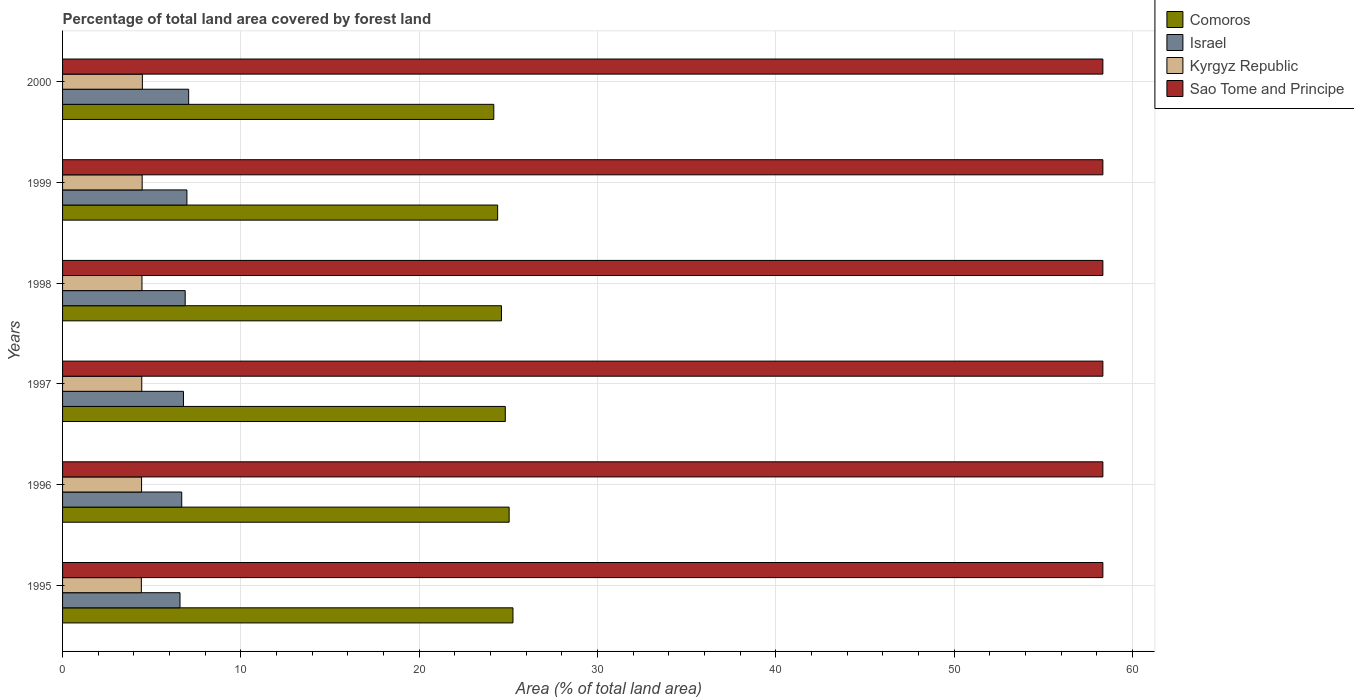How many bars are there on the 1st tick from the top?
Offer a terse response. 4. How many bars are there on the 4th tick from the bottom?
Ensure brevity in your answer.  4. What is the percentage of forest land in Sao Tome and Principe in 1998?
Ensure brevity in your answer.  58.33. Across all years, what is the maximum percentage of forest land in Kyrgyz Republic?
Provide a short and direct response. 4.47. Across all years, what is the minimum percentage of forest land in Kyrgyz Republic?
Keep it short and to the point. 4.42. What is the total percentage of forest land in Comoros in the graph?
Ensure brevity in your answer.  148.31. What is the difference between the percentage of forest land in Israel in 1996 and that in 2000?
Provide a short and direct response. -0.39. What is the difference between the percentage of forest land in Comoros in 1995 and the percentage of forest land in Sao Tome and Principe in 1998?
Your response must be concise. -33.08. What is the average percentage of forest land in Sao Tome and Principe per year?
Ensure brevity in your answer.  58.33. In the year 1998, what is the difference between the percentage of forest land in Kyrgyz Republic and percentage of forest land in Sao Tome and Principe?
Provide a succinct answer. -53.88. In how many years, is the percentage of forest land in Comoros greater than 18 %?
Your answer should be very brief. 6. What is the ratio of the percentage of forest land in Israel in 1995 to that in 1999?
Give a very brief answer. 0.94. Is the percentage of forest land in Israel in 1997 less than that in 1998?
Your response must be concise. Yes. What is the difference between the highest and the second highest percentage of forest land in Sao Tome and Principe?
Your answer should be very brief. 0. What is the difference between the highest and the lowest percentage of forest land in Israel?
Provide a short and direct response. 0.49. What does the 1st bar from the bottom in 1999 represents?
Your answer should be very brief. Comoros. Is it the case that in every year, the sum of the percentage of forest land in Sao Tome and Principe and percentage of forest land in Comoros is greater than the percentage of forest land in Kyrgyz Republic?
Provide a succinct answer. Yes. Are all the bars in the graph horizontal?
Offer a very short reply. Yes. How many years are there in the graph?
Provide a short and direct response. 6. Does the graph contain any zero values?
Provide a succinct answer. No. How many legend labels are there?
Offer a terse response. 4. How are the legend labels stacked?
Offer a terse response. Vertical. What is the title of the graph?
Make the answer very short. Percentage of total land area covered by forest land. What is the label or title of the X-axis?
Ensure brevity in your answer.  Area (% of total land area). What is the label or title of the Y-axis?
Offer a terse response. Years. What is the Area (% of total land area) of Comoros in 1995?
Offer a very short reply. 25.26. What is the Area (% of total land area) of Israel in 1995?
Offer a terse response. 6.59. What is the Area (% of total land area) of Kyrgyz Republic in 1995?
Your response must be concise. 4.42. What is the Area (% of total land area) of Sao Tome and Principe in 1995?
Offer a very short reply. 58.33. What is the Area (% of total land area) in Comoros in 1996?
Your answer should be compact. 25.04. What is the Area (% of total land area) of Israel in 1996?
Your answer should be very brief. 6.68. What is the Area (% of total land area) in Kyrgyz Republic in 1996?
Make the answer very short. 4.43. What is the Area (% of total land area) in Sao Tome and Principe in 1996?
Provide a succinct answer. 58.33. What is the Area (% of total land area) in Comoros in 1997?
Your answer should be very brief. 24.83. What is the Area (% of total land area) in Israel in 1997?
Offer a terse response. 6.78. What is the Area (% of total land area) in Kyrgyz Republic in 1997?
Offer a very short reply. 4.44. What is the Area (% of total land area) in Sao Tome and Principe in 1997?
Your answer should be compact. 58.33. What is the Area (% of total land area) of Comoros in 1998?
Provide a short and direct response. 24.61. What is the Area (% of total land area) in Israel in 1998?
Offer a very short reply. 6.88. What is the Area (% of total land area) of Kyrgyz Republic in 1998?
Offer a very short reply. 4.45. What is the Area (% of total land area) in Sao Tome and Principe in 1998?
Keep it short and to the point. 58.33. What is the Area (% of total land area) in Comoros in 1999?
Ensure brevity in your answer.  24.4. What is the Area (% of total land area) in Israel in 1999?
Ensure brevity in your answer.  6.97. What is the Area (% of total land area) of Kyrgyz Republic in 1999?
Provide a short and direct response. 4.46. What is the Area (% of total land area) in Sao Tome and Principe in 1999?
Give a very brief answer. 58.33. What is the Area (% of total land area) in Comoros in 2000?
Provide a short and direct response. 24.18. What is the Area (% of total land area) of Israel in 2000?
Provide a succinct answer. 7.07. What is the Area (% of total land area) in Kyrgyz Republic in 2000?
Offer a terse response. 4.47. What is the Area (% of total land area) of Sao Tome and Principe in 2000?
Provide a short and direct response. 58.33. Across all years, what is the maximum Area (% of total land area) in Comoros?
Give a very brief answer. 25.26. Across all years, what is the maximum Area (% of total land area) in Israel?
Offer a very short reply. 7.07. Across all years, what is the maximum Area (% of total land area) of Kyrgyz Republic?
Provide a short and direct response. 4.47. Across all years, what is the maximum Area (% of total land area) of Sao Tome and Principe?
Offer a terse response. 58.33. Across all years, what is the minimum Area (% of total land area) of Comoros?
Give a very brief answer. 24.18. Across all years, what is the minimum Area (% of total land area) of Israel?
Keep it short and to the point. 6.59. Across all years, what is the minimum Area (% of total land area) of Kyrgyz Republic?
Your answer should be compact. 4.42. Across all years, what is the minimum Area (% of total land area) in Sao Tome and Principe?
Make the answer very short. 58.33. What is the total Area (% of total land area) of Comoros in the graph?
Give a very brief answer. 148.31. What is the total Area (% of total land area) in Israel in the graph?
Your answer should be compact. 40.97. What is the total Area (% of total land area) of Kyrgyz Republic in the graph?
Ensure brevity in your answer.  26.68. What is the total Area (% of total land area) of Sao Tome and Principe in the graph?
Your answer should be very brief. 350. What is the difference between the Area (% of total land area) of Comoros in 1995 and that in 1996?
Give a very brief answer. 0.21. What is the difference between the Area (% of total land area) of Israel in 1995 and that in 1996?
Provide a short and direct response. -0.1. What is the difference between the Area (% of total land area) of Kyrgyz Republic in 1995 and that in 1996?
Your response must be concise. -0.01. What is the difference between the Area (% of total land area) of Sao Tome and Principe in 1995 and that in 1996?
Offer a very short reply. 0. What is the difference between the Area (% of total land area) in Comoros in 1995 and that in 1997?
Ensure brevity in your answer.  0.43. What is the difference between the Area (% of total land area) in Israel in 1995 and that in 1997?
Your response must be concise. -0.19. What is the difference between the Area (% of total land area) of Kyrgyz Republic in 1995 and that in 1997?
Your answer should be very brief. -0.02. What is the difference between the Area (% of total land area) in Comoros in 1995 and that in 1998?
Provide a succinct answer. 0.64. What is the difference between the Area (% of total land area) in Israel in 1995 and that in 1998?
Your response must be concise. -0.29. What is the difference between the Area (% of total land area) of Kyrgyz Republic in 1995 and that in 1998?
Offer a terse response. -0.03. What is the difference between the Area (% of total land area) of Comoros in 1995 and that in 1999?
Keep it short and to the point. 0.86. What is the difference between the Area (% of total land area) in Israel in 1995 and that in 1999?
Give a very brief answer. -0.39. What is the difference between the Area (% of total land area) in Kyrgyz Republic in 1995 and that in 1999?
Make the answer very short. -0.05. What is the difference between the Area (% of total land area) in Sao Tome and Principe in 1995 and that in 1999?
Offer a very short reply. 0. What is the difference between the Area (% of total land area) in Comoros in 1995 and that in 2000?
Make the answer very short. 1.07. What is the difference between the Area (% of total land area) in Israel in 1995 and that in 2000?
Provide a short and direct response. -0.49. What is the difference between the Area (% of total land area) in Kyrgyz Republic in 1995 and that in 2000?
Make the answer very short. -0.06. What is the difference between the Area (% of total land area) of Comoros in 1996 and that in 1997?
Your answer should be very brief. 0.21. What is the difference between the Area (% of total land area) of Israel in 1996 and that in 1997?
Keep it short and to the point. -0.1. What is the difference between the Area (% of total land area) of Kyrgyz Republic in 1996 and that in 1997?
Your answer should be very brief. -0.01. What is the difference between the Area (% of total land area) in Comoros in 1996 and that in 1998?
Your response must be concise. 0.43. What is the difference between the Area (% of total land area) in Israel in 1996 and that in 1998?
Your response must be concise. -0.19. What is the difference between the Area (% of total land area) in Kyrgyz Republic in 1996 and that in 1998?
Your response must be concise. -0.02. What is the difference between the Area (% of total land area) in Comoros in 1996 and that in 1999?
Give a very brief answer. 0.64. What is the difference between the Area (% of total land area) in Israel in 1996 and that in 1999?
Provide a succinct answer. -0.29. What is the difference between the Area (% of total land area) of Kyrgyz Republic in 1996 and that in 1999?
Your response must be concise. -0.03. What is the difference between the Area (% of total land area) of Sao Tome and Principe in 1996 and that in 1999?
Provide a succinct answer. 0. What is the difference between the Area (% of total land area) in Comoros in 1996 and that in 2000?
Keep it short and to the point. 0.86. What is the difference between the Area (% of total land area) in Israel in 1996 and that in 2000?
Provide a short and direct response. -0.39. What is the difference between the Area (% of total land area) in Kyrgyz Republic in 1996 and that in 2000?
Your response must be concise. -0.05. What is the difference between the Area (% of total land area) in Sao Tome and Principe in 1996 and that in 2000?
Your answer should be compact. 0. What is the difference between the Area (% of total land area) in Comoros in 1997 and that in 1998?
Give a very brief answer. 0.21. What is the difference between the Area (% of total land area) in Israel in 1997 and that in 1998?
Make the answer very short. -0.1. What is the difference between the Area (% of total land area) of Kyrgyz Republic in 1997 and that in 1998?
Give a very brief answer. -0.01. What is the difference between the Area (% of total land area) in Sao Tome and Principe in 1997 and that in 1998?
Your answer should be compact. 0. What is the difference between the Area (% of total land area) in Comoros in 1997 and that in 1999?
Make the answer very short. 0.43. What is the difference between the Area (% of total land area) of Israel in 1997 and that in 1999?
Your answer should be compact. -0.19. What is the difference between the Area (% of total land area) of Kyrgyz Republic in 1997 and that in 1999?
Make the answer very short. -0.02. What is the difference between the Area (% of total land area) in Sao Tome and Principe in 1997 and that in 1999?
Your response must be concise. 0. What is the difference between the Area (% of total land area) in Comoros in 1997 and that in 2000?
Your response must be concise. 0.64. What is the difference between the Area (% of total land area) in Israel in 1997 and that in 2000?
Keep it short and to the point. -0.29. What is the difference between the Area (% of total land area) in Kyrgyz Republic in 1997 and that in 2000?
Keep it short and to the point. -0.03. What is the difference between the Area (% of total land area) in Comoros in 1998 and that in 1999?
Your answer should be compact. 0.21. What is the difference between the Area (% of total land area) of Israel in 1998 and that in 1999?
Your answer should be very brief. -0.1. What is the difference between the Area (% of total land area) of Kyrgyz Republic in 1998 and that in 1999?
Offer a very short reply. -0.01. What is the difference between the Area (% of total land area) of Comoros in 1998 and that in 2000?
Keep it short and to the point. 0.43. What is the difference between the Area (% of total land area) in Israel in 1998 and that in 2000?
Make the answer very short. -0.19. What is the difference between the Area (% of total land area) in Kyrgyz Republic in 1998 and that in 2000?
Offer a very short reply. -0.02. What is the difference between the Area (% of total land area) of Sao Tome and Principe in 1998 and that in 2000?
Offer a very short reply. 0. What is the difference between the Area (% of total land area) of Comoros in 1999 and that in 2000?
Make the answer very short. 0.21. What is the difference between the Area (% of total land area) of Israel in 1999 and that in 2000?
Ensure brevity in your answer.  -0.1. What is the difference between the Area (% of total land area) in Kyrgyz Republic in 1999 and that in 2000?
Your answer should be compact. -0.01. What is the difference between the Area (% of total land area) of Sao Tome and Principe in 1999 and that in 2000?
Provide a short and direct response. 0. What is the difference between the Area (% of total land area) in Comoros in 1995 and the Area (% of total land area) in Israel in 1996?
Your response must be concise. 18.57. What is the difference between the Area (% of total land area) of Comoros in 1995 and the Area (% of total land area) of Kyrgyz Republic in 1996?
Ensure brevity in your answer.  20.83. What is the difference between the Area (% of total land area) in Comoros in 1995 and the Area (% of total land area) in Sao Tome and Principe in 1996?
Ensure brevity in your answer.  -33.08. What is the difference between the Area (% of total land area) of Israel in 1995 and the Area (% of total land area) of Kyrgyz Republic in 1996?
Provide a short and direct response. 2.16. What is the difference between the Area (% of total land area) of Israel in 1995 and the Area (% of total land area) of Sao Tome and Principe in 1996?
Offer a very short reply. -51.75. What is the difference between the Area (% of total land area) in Kyrgyz Republic in 1995 and the Area (% of total land area) in Sao Tome and Principe in 1996?
Your response must be concise. -53.92. What is the difference between the Area (% of total land area) of Comoros in 1995 and the Area (% of total land area) of Israel in 1997?
Provide a short and direct response. 18.48. What is the difference between the Area (% of total land area) in Comoros in 1995 and the Area (% of total land area) in Kyrgyz Republic in 1997?
Ensure brevity in your answer.  20.81. What is the difference between the Area (% of total land area) of Comoros in 1995 and the Area (% of total land area) of Sao Tome and Principe in 1997?
Offer a terse response. -33.08. What is the difference between the Area (% of total land area) of Israel in 1995 and the Area (% of total land area) of Kyrgyz Republic in 1997?
Keep it short and to the point. 2.14. What is the difference between the Area (% of total land area) in Israel in 1995 and the Area (% of total land area) in Sao Tome and Principe in 1997?
Give a very brief answer. -51.75. What is the difference between the Area (% of total land area) of Kyrgyz Republic in 1995 and the Area (% of total land area) of Sao Tome and Principe in 1997?
Keep it short and to the point. -53.92. What is the difference between the Area (% of total land area) of Comoros in 1995 and the Area (% of total land area) of Israel in 1998?
Provide a short and direct response. 18.38. What is the difference between the Area (% of total land area) in Comoros in 1995 and the Area (% of total land area) in Kyrgyz Republic in 1998?
Keep it short and to the point. 20.8. What is the difference between the Area (% of total land area) of Comoros in 1995 and the Area (% of total land area) of Sao Tome and Principe in 1998?
Your answer should be compact. -33.08. What is the difference between the Area (% of total land area) of Israel in 1995 and the Area (% of total land area) of Kyrgyz Republic in 1998?
Offer a very short reply. 2.13. What is the difference between the Area (% of total land area) of Israel in 1995 and the Area (% of total land area) of Sao Tome and Principe in 1998?
Your answer should be very brief. -51.75. What is the difference between the Area (% of total land area) of Kyrgyz Republic in 1995 and the Area (% of total land area) of Sao Tome and Principe in 1998?
Ensure brevity in your answer.  -53.92. What is the difference between the Area (% of total land area) of Comoros in 1995 and the Area (% of total land area) of Israel in 1999?
Offer a terse response. 18.28. What is the difference between the Area (% of total land area) of Comoros in 1995 and the Area (% of total land area) of Kyrgyz Republic in 1999?
Ensure brevity in your answer.  20.79. What is the difference between the Area (% of total land area) of Comoros in 1995 and the Area (% of total land area) of Sao Tome and Principe in 1999?
Provide a succinct answer. -33.08. What is the difference between the Area (% of total land area) of Israel in 1995 and the Area (% of total land area) of Kyrgyz Republic in 1999?
Your answer should be compact. 2.12. What is the difference between the Area (% of total land area) of Israel in 1995 and the Area (% of total land area) of Sao Tome and Principe in 1999?
Your answer should be compact. -51.75. What is the difference between the Area (% of total land area) of Kyrgyz Republic in 1995 and the Area (% of total land area) of Sao Tome and Principe in 1999?
Provide a short and direct response. -53.92. What is the difference between the Area (% of total land area) in Comoros in 1995 and the Area (% of total land area) in Israel in 2000?
Provide a short and direct response. 18.18. What is the difference between the Area (% of total land area) of Comoros in 1995 and the Area (% of total land area) of Kyrgyz Republic in 2000?
Your answer should be very brief. 20.78. What is the difference between the Area (% of total land area) in Comoros in 1995 and the Area (% of total land area) in Sao Tome and Principe in 2000?
Offer a very short reply. -33.08. What is the difference between the Area (% of total land area) of Israel in 1995 and the Area (% of total land area) of Kyrgyz Republic in 2000?
Your answer should be compact. 2.11. What is the difference between the Area (% of total land area) in Israel in 1995 and the Area (% of total land area) in Sao Tome and Principe in 2000?
Ensure brevity in your answer.  -51.75. What is the difference between the Area (% of total land area) of Kyrgyz Republic in 1995 and the Area (% of total land area) of Sao Tome and Principe in 2000?
Provide a short and direct response. -53.92. What is the difference between the Area (% of total land area) of Comoros in 1996 and the Area (% of total land area) of Israel in 1997?
Provide a succinct answer. 18.26. What is the difference between the Area (% of total land area) in Comoros in 1996 and the Area (% of total land area) in Kyrgyz Republic in 1997?
Make the answer very short. 20.6. What is the difference between the Area (% of total land area) of Comoros in 1996 and the Area (% of total land area) of Sao Tome and Principe in 1997?
Make the answer very short. -33.29. What is the difference between the Area (% of total land area) in Israel in 1996 and the Area (% of total land area) in Kyrgyz Republic in 1997?
Offer a very short reply. 2.24. What is the difference between the Area (% of total land area) in Israel in 1996 and the Area (% of total land area) in Sao Tome and Principe in 1997?
Your answer should be compact. -51.65. What is the difference between the Area (% of total land area) of Kyrgyz Republic in 1996 and the Area (% of total land area) of Sao Tome and Principe in 1997?
Give a very brief answer. -53.9. What is the difference between the Area (% of total land area) in Comoros in 1996 and the Area (% of total land area) in Israel in 1998?
Ensure brevity in your answer.  18.16. What is the difference between the Area (% of total land area) of Comoros in 1996 and the Area (% of total land area) of Kyrgyz Republic in 1998?
Provide a short and direct response. 20.59. What is the difference between the Area (% of total land area) in Comoros in 1996 and the Area (% of total land area) in Sao Tome and Principe in 1998?
Offer a terse response. -33.29. What is the difference between the Area (% of total land area) in Israel in 1996 and the Area (% of total land area) in Kyrgyz Republic in 1998?
Your answer should be very brief. 2.23. What is the difference between the Area (% of total land area) of Israel in 1996 and the Area (% of total land area) of Sao Tome and Principe in 1998?
Your response must be concise. -51.65. What is the difference between the Area (% of total land area) of Kyrgyz Republic in 1996 and the Area (% of total land area) of Sao Tome and Principe in 1998?
Give a very brief answer. -53.9. What is the difference between the Area (% of total land area) in Comoros in 1996 and the Area (% of total land area) in Israel in 1999?
Keep it short and to the point. 18.07. What is the difference between the Area (% of total land area) of Comoros in 1996 and the Area (% of total land area) of Kyrgyz Republic in 1999?
Offer a terse response. 20.58. What is the difference between the Area (% of total land area) in Comoros in 1996 and the Area (% of total land area) in Sao Tome and Principe in 1999?
Offer a terse response. -33.29. What is the difference between the Area (% of total land area) of Israel in 1996 and the Area (% of total land area) of Kyrgyz Republic in 1999?
Make the answer very short. 2.22. What is the difference between the Area (% of total land area) of Israel in 1996 and the Area (% of total land area) of Sao Tome and Principe in 1999?
Make the answer very short. -51.65. What is the difference between the Area (% of total land area) of Kyrgyz Republic in 1996 and the Area (% of total land area) of Sao Tome and Principe in 1999?
Provide a succinct answer. -53.9. What is the difference between the Area (% of total land area) of Comoros in 1996 and the Area (% of total land area) of Israel in 2000?
Ensure brevity in your answer.  17.97. What is the difference between the Area (% of total land area) of Comoros in 1996 and the Area (% of total land area) of Kyrgyz Republic in 2000?
Your response must be concise. 20.57. What is the difference between the Area (% of total land area) of Comoros in 1996 and the Area (% of total land area) of Sao Tome and Principe in 2000?
Keep it short and to the point. -33.29. What is the difference between the Area (% of total land area) of Israel in 1996 and the Area (% of total land area) of Kyrgyz Republic in 2000?
Make the answer very short. 2.21. What is the difference between the Area (% of total land area) in Israel in 1996 and the Area (% of total land area) in Sao Tome and Principe in 2000?
Make the answer very short. -51.65. What is the difference between the Area (% of total land area) of Kyrgyz Republic in 1996 and the Area (% of total land area) of Sao Tome and Principe in 2000?
Your answer should be compact. -53.9. What is the difference between the Area (% of total land area) in Comoros in 1997 and the Area (% of total land area) in Israel in 1998?
Your response must be concise. 17.95. What is the difference between the Area (% of total land area) in Comoros in 1997 and the Area (% of total land area) in Kyrgyz Republic in 1998?
Give a very brief answer. 20.37. What is the difference between the Area (% of total land area) of Comoros in 1997 and the Area (% of total land area) of Sao Tome and Principe in 1998?
Offer a very short reply. -33.51. What is the difference between the Area (% of total land area) in Israel in 1997 and the Area (% of total land area) in Kyrgyz Republic in 1998?
Give a very brief answer. 2.33. What is the difference between the Area (% of total land area) in Israel in 1997 and the Area (% of total land area) in Sao Tome and Principe in 1998?
Make the answer very short. -51.55. What is the difference between the Area (% of total land area) in Kyrgyz Republic in 1997 and the Area (% of total land area) in Sao Tome and Principe in 1998?
Ensure brevity in your answer.  -53.89. What is the difference between the Area (% of total land area) of Comoros in 1997 and the Area (% of total land area) of Israel in 1999?
Your answer should be very brief. 17.85. What is the difference between the Area (% of total land area) in Comoros in 1997 and the Area (% of total land area) in Kyrgyz Republic in 1999?
Offer a very short reply. 20.36. What is the difference between the Area (% of total land area) in Comoros in 1997 and the Area (% of total land area) in Sao Tome and Principe in 1999?
Your response must be concise. -33.51. What is the difference between the Area (% of total land area) in Israel in 1997 and the Area (% of total land area) in Kyrgyz Republic in 1999?
Your response must be concise. 2.32. What is the difference between the Area (% of total land area) in Israel in 1997 and the Area (% of total land area) in Sao Tome and Principe in 1999?
Your answer should be very brief. -51.55. What is the difference between the Area (% of total land area) of Kyrgyz Republic in 1997 and the Area (% of total land area) of Sao Tome and Principe in 1999?
Your response must be concise. -53.89. What is the difference between the Area (% of total land area) in Comoros in 1997 and the Area (% of total land area) in Israel in 2000?
Your answer should be compact. 17.76. What is the difference between the Area (% of total land area) in Comoros in 1997 and the Area (% of total land area) in Kyrgyz Republic in 2000?
Give a very brief answer. 20.35. What is the difference between the Area (% of total land area) in Comoros in 1997 and the Area (% of total land area) in Sao Tome and Principe in 2000?
Offer a terse response. -33.51. What is the difference between the Area (% of total land area) of Israel in 1997 and the Area (% of total land area) of Kyrgyz Republic in 2000?
Your response must be concise. 2.3. What is the difference between the Area (% of total land area) in Israel in 1997 and the Area (% of total land area) in Sao Tome and Principe in 2000?
Ensure brevity in your answer.  -51.55. What is the difference between the Area (% of total land area) of Kyrgyz Republic in 1997 and the Area (% of total land area) of Sao Tome and Principe in 2000?
Provide a short and direct response. -53.89. What is the difference between the Area (% of total land area) in Comoros in 1998 and the Area (% of total land area) in Israel in 1999?
Provide a succinct answer. 17.64. What is the difference between the Area (% of total land area) of Comoros in 1998 and the Area (% of total land area) of Kyrgyz Republic in 1999?
Your answer should be very brief. 20.15. What is the difference between the Area (% of total land area) of Comoros in 1998 and the Area (% of total land area) of Sao Tome and Principe in 1999?
Give a very brief answer. -33.72. What is the difference between the Area (% of total land area) of Israel in 1998 and the Area (% of total land area) of Kyrgyz Republic in 1999?
Offer a terse response. 2.41. What is the difference between the Area (% of total land area) in Israel in 1998 and the Area (% of total land area) in Sao Tome and Principe in 1999?
Offer a terse response. -51.46. What is the difference between the Area (% of total land area) of Kyrgyz Republic in 1998 and the Area (% of total land area) of Sao Tome and Principe in 1999?
Make the answer very short. -53.88. What is the difference between the Area (% of total land area) of Comoros in 1998 and the Area (% of total land area) of Israel in 2000?
Make the answer very short. 17.54. What is the difference between the Area (% of total land area) in Comoros in 1998 and the Area (% of total land area) in Kyrgyz Republic in 2000?
Provide a short and direct response. 20.14. What is the difference between the Area (% of total land area) of Comoros in 1998 and the Area (% of total land area) of Sao Tome and Principe in 2000?
Provide a short and direct response. -33.72. What is the difference between the Area (% of total land area) in Israel in 1998 and the Area (% of total land area) in Kyrgyz Republic in 2000?
Ensure brevity in your answer.  2.4. What is the difference between the Area (% of total land area) in Israel in 1998 and the Area (% of total land area) in Sao Tome and Principe in 2000?
Ensure brevity in your answer.  -51.46. What is the difference between the Area (% of total land area) of Kyrgyz Republic in 1998 and the Area (% of total land area) of Sao Tome and Principe in 2000?
Your answer should be compact. -53.88. What is the difference between the Area (% of total land area) of Comoros in 1999 and the Area (% of total land area) of Israel in 2000?
Offer a terse response. 17.33. What is the difference between the Area (% of total land area) in Comoros in 1999 and the Area (% of total land area) in Kyrgyz Republic in 2000?
Ensure brevity in your answer.  19.92. What is the difference between the Area (% of total land area) in Comoros in 1999 and the Area (% of total land area) in Sao Tome and Principe in 2000?
Provide a succinct answer. -33.94. What is the difference between the Area (% of total land area) of Israel in 1999 and the Area (% of total land area) of Kyrgyz Republic in 2000?
Give a very brief answer. 2.5. What is the difference between the Area (% of total land area) of Israel in 1999 and the Area (% of total land area) of Sao Tome and Principe in 2000?
Your response must be concise. -51.36. What is the difference between the Area (% of total land area) of Kyrgyz Republic in 1999 and the Area (% of total land area) of Sao Tome and Principe in 2000?
Make the answer very short. -53.87. What is the average Area (% of total land area) of Comoros per year?
Keep it short and to the point. 24.72. What is the average Area (% of total land area) of Israel per year?
Your response must be concise. 6.83. What is the average Area (% of total land area) of Kyrgyz Republic per year?
Your answer should be compact. 4.45. What is the average Area (% of total land area) of Sao Tome and Principe per year?
Provide a succinct answer. 58.33. In the year 1995, what is the difference between the Area (% of total land area) in Comoros and Area (% of total land area) in Israel?
Offer a very short reply. 18.67. In the year 1995, what is the difference between the Area (% of total land area) of Comoros and Area (% of total land area) of Kyrgyz Republic?
Offer a very short reply. 20.84. In the year 1995, what is the difference between the Area (% of total land area) of Comoros and Area (% of total land area) of Sao Tome and Principe?
Offer a very short reply. -33.08. In the year 1995, what is the difference between the Area (% of total land area) of Israel and Area (% of total land area) of Kyrgyz Republic?
Keep it short and to the point. 2.17. In the year 1995, what is the difference between the Area (% of total land area) in Israel and Area (% of total land area) in Sao Tome and Principe?
Give a very brief answer. -51.75. In the year 1995, what is the difference between the Area (% of total land area) in Kyrgyz Republic and Area (% of total land area) in Sao Tome and Principe?
Make the answer very short. -53.92. In the year 1996, what is the difference between the Area (% of total land area) in Comoros and Area (% of total land area) in Israel?
Your response must be concise. 18.36. In the year 1996, what is the difference between the Area (% of total land area) of Comoros and Area (% of total land area) of Kyrgyz Republic?
Your answer should be compact. 20.61. In the year 1996, what is the difference between the Area (% of total land area) in Comoros and Area (% of total land area) in Sao Tome and Principe?
Keep it short and to the point. -33.29. In the year 1996, what is the difference between the Area (% of total land area) in Israel and Area (% of total land area) in Kyrgyz Republic?
Your answer should be compact. 2.25. In the year 1996, what is the difference between the Area (% of total land area) of Israel and Area (% of total land area) of Sao Tome and Principe?
Offer a very short reply. -51.65. In the year 1996, what is the difference between the Area (% of total land area) of Kyrgyz Republic and Area (% of total land area) of Sao Tome and Principe?
Your response must be concise. -53.9. In the year 1997, what is the difference between the Area (% of total land area) in Comoros and Area (% of total land area) in Israel?
Offer a very short reply. 18.05. In the year 1997, what is the difference between the Area (% of total land area) in Comoros and Area (% of total land area) in Kyrgyz Republic?
Provide a succinct answer. 20.38. In the year 1997, what is the difference between the Area (% of total land area) in Comoros and Area (% of total land area) in Sao Tome and Principe?
Make the answer very short. -33.51. In the year 1997, what is the difference between the Area (% of total land area) in Israel and Area (% of total land area) in Kyrgyz Republic?
Your answer should be very brief. 2.34. In the year 1997, what is the difference between the Area (% of total land area) in Israel and Area (% of total land area) in Sao Tome and Principe?
Provide a succinct answer. -51.55. In the year 1997, what is the difference between the Area (% of total land area) in Kyrgyz Republic and Area (% of total land area) in Sao Tome and Principe?
Your answer should be compact. -53.89. In the year 1998, what is the difference between the Area (% of total land area) of Comoros and Area (% of total land area) of Israel?
Provide a short and direct response. 17.73. In the year 1998, what is the difference between the Area (% of total land area) in Comoros and Area (% of total land area) in Kyrgyz Republic?
Provide a succinct answer. 20.16. In the year 1998, what is the difference between the Area (% of total land area) in Comoros and Area (% of total land area) in Sao Tome and Principe?
Your answer should be very brief. -33.72. In the year 1998, what is the difference between the Area (% of total land area) in Israel and Area (% of total land area) in Kyrgyz Republic?
Offer a terse response. 2.42. In the year 1998, what is the difference between the Area (% of total land area) of Israel and Area (% of total land area) of Sao Tome and Principe?
Keep it short and to the point. -51.46. In the year 1998, what is the difference between the Area (% of total land area) of Kyrgyz Republic and Area (% of total land area) of Sao Tome and Principe?
Provide a succinct answer. -53.88. In the year 1999, what is the difference between the Area (% of total land area) in Comoros and Area (% of total land area) in Israel?
Give a very brief answer. 17.42. In the year 1999, what is the difference between the Area (% of total land area) of Comoros and Area (% of total land area) of Kyrgyz Republic?
Keep it short and to the point. 19.93. In the year 1999, what is the difference between the Area (% of total land area) in Comoros and Area (% of total land area) in Sao Tome and Principe?
Your answer should be very brief. -33.94. In the year 1999, what is the difference between the Area (% of total land area) of Israel and Area (% of total land area) of Kyrgyz Republic?
Provide a short and direct response. 2.51. In the year 1999, what is the difference between the Area (% of total land area) of Israel and Area (% of total land area) of Sao Tome and Principe?
Keep it short and to the point. -51.36. In the year 1999, what is the difference between the Area (% of total land area) in Kyrgyz Republic and Area (% of total land area) in Sao Tome and Principe?
Your answer should be very brief. -53.87. In the year 2000, what is the difference between the Area (% of total land area) of Comoros and Area (% of total land area) of Israel?
Make the answer very short. 17.11. In the year 2000, what is the difference between the Area (% of total land area) of Comoros and Area (% of total land area) of Kyrgyz Republic?
Offer a very short reply. 19.71. In the year 2000, what is the difference between the Area (% of total land area) of Comoros and Area (% of total land area) of Sao Tome and Principe?
Give a very brief answer. -34.15. In the year 2000, what is the difference between the Area (% of total land area) of Israel and Area (% of total land area) of Kyrgyz Republic?
Your response must be concise. 2.6. In the year 2000, what is the difference between the Area (% of total land area) of Israel and Area (% of total land area) of Sao Tome and Principe?
Your response must be concise. -51.26. In the year 2000, what is the difference between the Area (% of total land area) in Kyrgyz Republic and Area (% of total land area) in Sao Tome and Principe?
Offer a very short reply. -53.86. What is the ratio of the Area (% of total land area) in Comoros in 1995 to that in 1996?
Provide a short and direct response. 1.01. What is the ratio of the Area (% of total land area) of Israel in 1995 to that in 1996?
Provide a short and direct response. 0.99. What is the ratio of the Area (% of total land area) of Comoros in 1995 to that in 1997?
Ensure brevity in your answer.  1.02. What is the ratio of the Area (% of total land area) of Israel in 1995 to that in 1997?
Make the answer very short. 0.97. What is the ratio of the Area (% of total land area) in Kyrgyz Republic in 1995 to that in 1997?
Provide a succinct answer. 0.99. What is the ratio of the Area (% of total land area) of Comoros in 1995 to that in 1998?
Offer a terse response. 1.03. What is the ratio of the Area (% of total land area) of Israel in 1995 to that in 1998?
Provide a short and direct response. 0.96. What is the ratio of the Area (% of total land area) of Kyrgyz Republic in 1995 to that in 1998?
Provide a succinct answer. 0.99. What is the ratio of the Area (% of total land area) in Sao Tome and Principe in 1995 to that in 1998?
Provide a short and direct response. 1. What is the ratio of the Area (% of total land area) of Comoros in 1995 to that in 1999?
Give a very brief answer. 1.04. What is the ratio of the Area (% of total land area) in Israel in 1995 to that in 1999?
Your answer should be compact. 0.94. What is the ratio of the Area (% of total land area) in Comoros in 1995 to that in 2000?
Your answer should be very brief. 1.04. What is the ratio of the Area (% of total land area) of Israel in 1995 to that in 2000?
Ensure brevity in your answer.  0.93. What is the ratio of the Area (% of total land area) of Kyrgyz Republic in 1995 to that in 2000?
Your answer should be very brief. 0.99. What is the ratio of the Area (% of total land area) in Sao Tome and Principe in 1995 to that in 2000?
Your answer should be very brief. 1. What is the ratio of the Area (% of total land area) in Comoros in 1996 to that in 1997?
Make the answer very short. 1.01. What is the ratio of the Area (% of total land area) of Israel in 1996 to that in 1997?
Your answer should be very brief. 0.99. What is the ratio of the Area (% of total land area) in Kyrgyz Republic in 1996 to that in 1997?
Your answer should be compact. 1. What is the ratio of the Area (% of total land area) in Sao Tome and Principe in 1996 to that in 1997?
Ensure brevity in your answer.  1. What is the ratio of the Area (% of total land area) of Comoros in 1996 to that in 1998?
Keep it short and to the point. 1.02. What is the ratio of the Area (% of total land area) in Israel in 1996 to that in 1998?
Keep it short and to the point. 0.97. What is the ratio of the Area (% of total land area) in Comoros in 1996 to that in 1999?
Ensure brevity in your answer.  1.03. What is the ratio of the Area (% of total land area) of Kyrgyz Republic in 1996 to that in 1999?
Provide a short and direct response. 0.99. What is the ratio of the Area (% of total land area) of Comoros in 1996 to that in 2000?
Give a very brief answer. 1.04. What is the ratio of the Area (% of total land area) in Israel in 1996 to that in 2000?
Your answer should be compact. 0.95. What is the ratio of the Area (% of total land area) of Sao Tome and Principe in 1996 to that in 2000?
Provide a short and direct response. 1. What is the ratio of the Area (% of total land area) in Comoros in 1997 to that in 1998?
Make the answer very short. 1.01. What is the ratio of the Area (% of total land area) of Israel in 1997 to that in 1998?
Provide a succinct answer. 0.99. What is the ratio of the Area (% of total land area) of Comoros in 1997 to that in 1999?
Provide a succinct answer. 1.02. What is the ratio of the Area (% of total land area) in Israel in 1997 to that in 1999?
Provide a short and direct response. 0.97. What is the ratio of the Area (% of total land area) in Comoros in 1997 to that in 2000?
Give a very brief answer. 1.03. What is the ratio of the Area (% of total land area) in Israel in 1997 to that in 2000?
Provide a succinct answer. 0.96. What is the ratio of the Area (% of total land area) of Kyrgyz Republic in 1997 to that in 2000?
Provide a short and direct response. 0.99. What is the ratio of the Area (% of total land area) of Comoros in 1998 to that in 1999?
Offer a terse response. 1.01. What is the ratio of the Area (% of total land area) in Israel in 1998 to that in 1999?
Your answer should be compact. 0.99. What is the ratio of the Area (% of total land area) of Sao Tome and Principe in 1998 to that in 1999?
Give a very brief answer. 1. What is the ratio of the Area (% of total land area) of Comoros in 1998 to that in 2000?
Offer a very short reply. 1.02. What is the ratio of the Area (% of total land area) in Israel in 1998 to that in 2000?
Make the answer very short. 0.97. What is the ratio of the Area (% of total land area) in Sao Tome and Principe in 1998 to that in 2000?
Provide a succinct answer. 1. What is the ratio of the Area (% of total land area) in Comoros in 1999 to that in 2000?
Your answer should be compact. 1.01. What is the ratio of the Area (% of total land area) of Israel in 1999 to that in 2000?
Provide a succinct answer. 0.99. What is the ratio of the Area (% of total land area) of Kyrgyz Republic in 1999 to that in 2000?
Your response must be concise. 1. What is the difference between the highest and the second highest Area (% of total land area) of Comoros?
Offer a terse response. 0.21. What is the difference between the highest and the second highest Area (% of total land area) in Israel?
Give a very brief answer. 0.1. What is the difference between the highest and the second highest Area (% of total land area) in Kyrgyz Republic?
Ensure brevity in your answer.  0.01. What is the difference between the highest and the lowest Area (% of total land area) in Comoros?
Offer a terse response. 1.07. What is the difference between the highest and the lowest Area (% of total land area) of Israel?
Provide a succinct answer. 0.49. What is the difference between the highest and the lowest Area (% of total land area) in Kyrgyz Republic?
Keep it short and to the point. 0.06. What is the difference between the highest and the lowest Area (% of total land area) in Sao Tome and Principe?
Your answer should be compact. 0. 